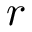Convert formula to latex. <formula><loc_0><loc_0><loc_500><loc_500>r</formula> 